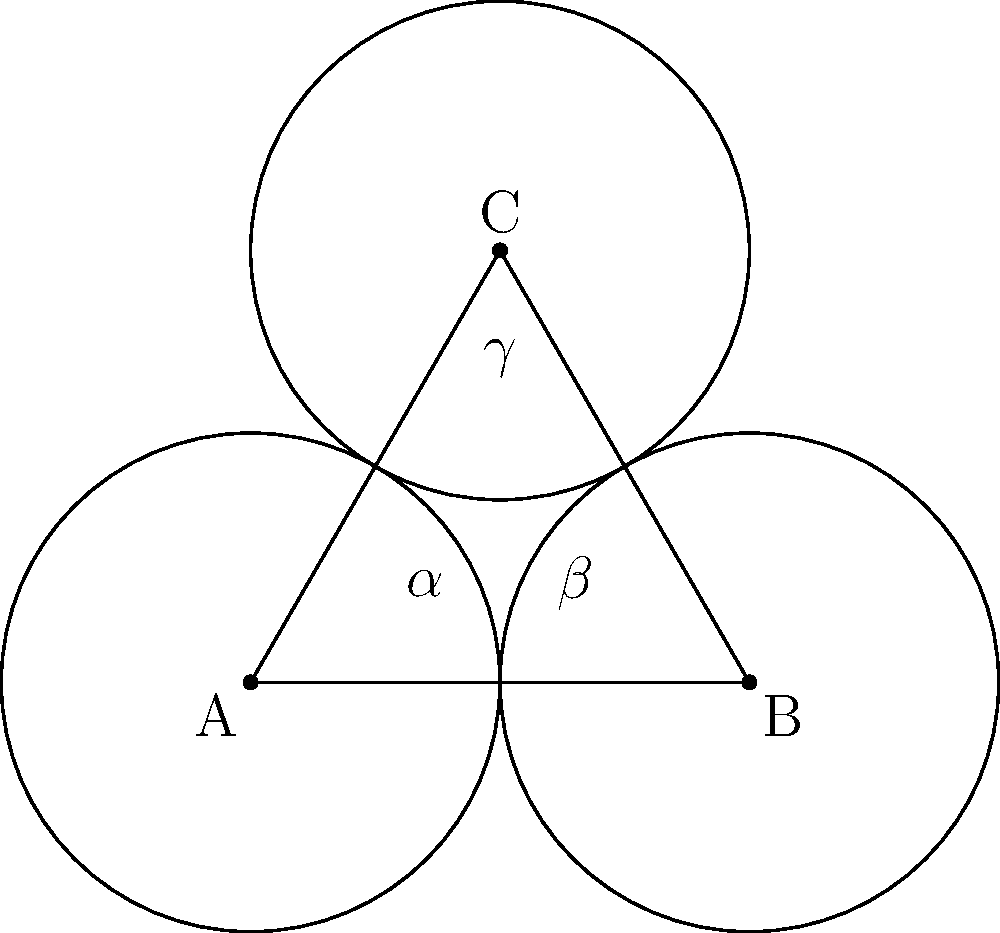In the crystal structure of a newly discovered pigment, we observe a triangular arrangement of atoms. The centers of these atoms form an equilateral triangle ABC with side length 2 units. If we consider each atom as a sphere with radius 1 unit, what is the area of the region where all three spheres overlap? Let's approach this step-by-step:

1) First, we need to recognize that the overlapping region forms a curved triangle known as a Reuleaux triangle.

2) The area of a Reuleaux triangle can be calculated using the formula:
   
   $$A = (\pi - \sqrt{3})r^2$$

   where $r$ is the radius of the circles.

3) In this case, $r = 1$ unit.

4) Substituting this into our formula:

   $$A = (\pi - \sqrt{3}) \cdot 1^2$$

5) Simplifying:
   
   $$A = \pi - \sqrt{3}$$

6) This can be left as is, or we can calculate an approximate numerical value:

   $$A \approx 3.14159 - 1.73205 \approx 1.40954$$

Thus, the area of the overlapping region is $\pi - \sqrt{3}$ square units, or approximately 1.41 square units.
Answer: $\pi - \sqrt{3}$ square units 